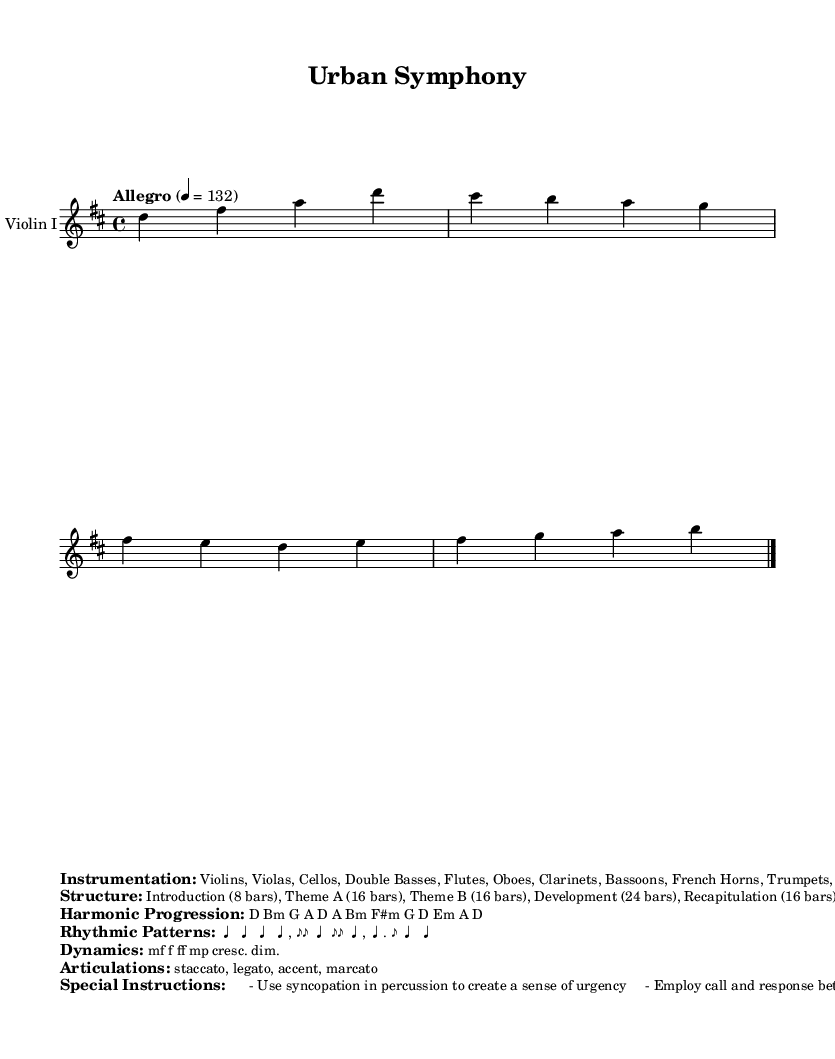What is the key signature of this music? The key signature displayed in the music indicates D major, which has two sharps (F# and C#). This can be identified from the global settings section of the LilyPond code where it specifies "\key d \major."
Answer: D major What is the time signature of this music? The time signature shown in the music is 4/4, indicating there are four beats per measure, which can be confirmed in the same global section specifying "\time 4/4."
Answer: 4/4 What tempo marking is indicated in the music? The tempo marking provided in the global section is "Allegro," with a specific metronome marking of 132 beats per minute. This is directly stated in the global settings of the code.
Answer: Allegro 132 How many bars are in the Introduction section? The structure of the music indicates that the Introduction consists of 8 bars. This information is provided in the structured section of the markup where it breaks down different parts of the piece.
Answer: 8 bars What is the main harmonic progression used in the piece? The harmonic progression mentioned in the markup section lists the sequence of chords as D, Bm, G, A, D, A, Bm, F#m, G, D, Em, A, D. This can be seen directly in the "Harmonic Progression" markup.
Answer: D Bm G A D A Bm F#m G D Em A D What special instructions are given regarding percussion? The special instructions state to use syncopation in percussion to create a sense of urgency. This directive is found in the "Special Instructions" part of the markup, emphasizing its importance in enhancing the piece's lively character.
Answer: Use syncopation in percussion Which instruments are included in the orchestration? The instruments listed in the orchestration include Violins, Violas, Cellos, Double Basses, Flutes, Oboes, Clarinets, Bassoons, French Horns, Trumpets, Trombones, Timpani, and Percussion (Snare Drum, Cymbals, Triangle). This information is provided in the "Instrumentation" section of the markup.
Answer: Violins, Violas, Cellos, Double Basses, Flutes, Oboes, Clarinets, Bassoons, French Horns, Trumpets, Trombones, Timpani, Percussion 